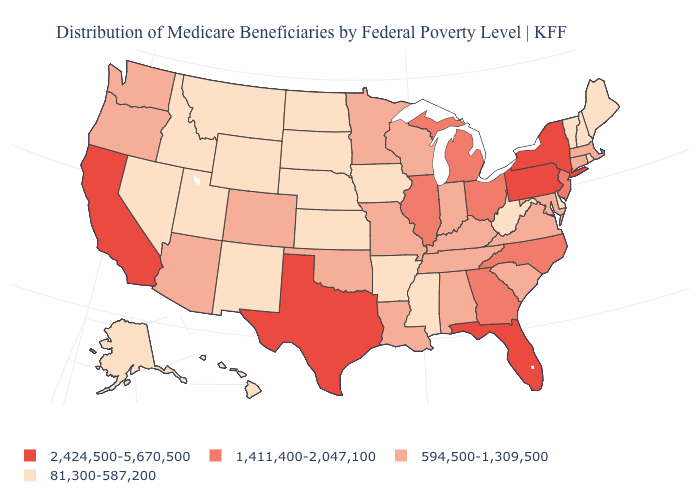Which states have the highest value in the USA?
Be succinct. California, Florida, New York, Pennsylvania, Texas. What is the value of Arizona?
Give a very brief answer. 594,500-1,309,500. Does the first symbol in the legend represent the smallest category?
Keep it brief. No. How many symbols are there in the legend?
Give a very brief answer. 4. What is the value of South Carolina?
Quick response, please. 594,500-1,309,500. How many symbols are there in the legend?
Give a very brief answer. 4. Name the states that have a value in the range 1,411,400-2,047,100?
Short answer required. Georgia, Illinois, Michigan, New Jersey, North Carolina, Ohio. What is the value of Georgia?
Keep it brief. 1,411,400-2,047,100. What is the value of Kentucky?
Short answer required. 594,500-1,309,500. What is the highest value in the USA?
Write a very short answer. 2,424,500-5,670,500. Among the states that border Arizona , which have the lowest value?
Give a very brief answer. Nevada, New Mexico, Utah. Which states have the lowest value in the USA?
Answer briefly. Alaska, Arkansas, Delaware, Hawaii, Idaho, Iowa, Kansas, Maine, Mississippi, Montana, Nebraska, Nevada, New Hampshire, New Mexico, North Dakota, Rhode Island, South Dakota, Utah, Vermont, West Virginia, Wyoming. What is the value of Utah?
Give a very brief answer. 81,300-587,200. Does West Virginia have the lowest value in the USA?
Give a very brief answer. Yes. Among the states that border Delaware , which have the highest value?
Give a very brief answer. Pennsylvania. 